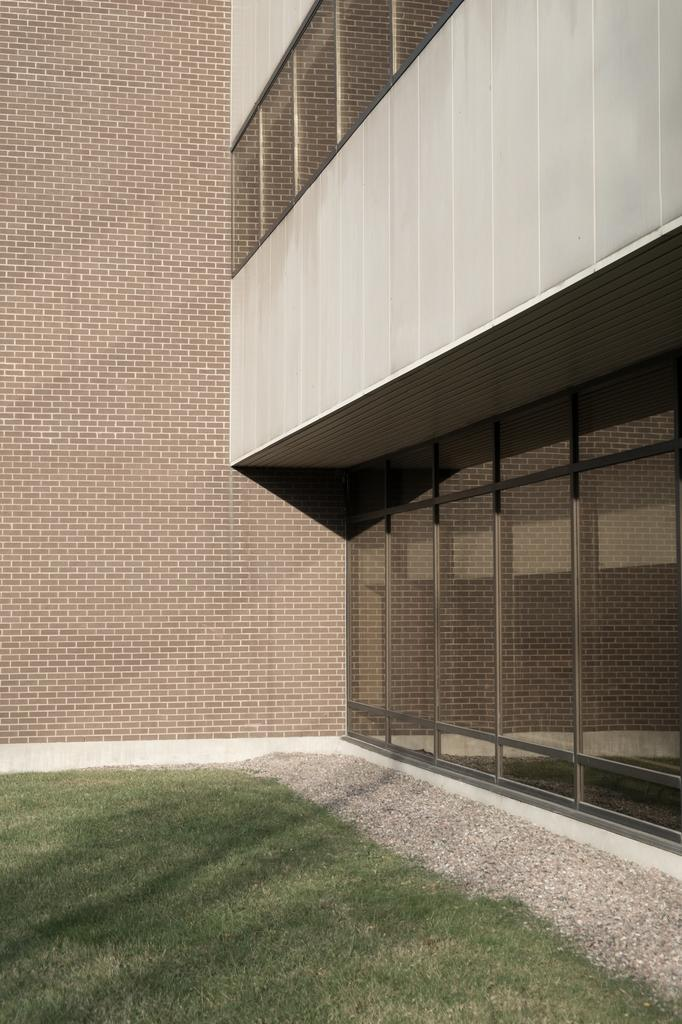What type of vegetation is present in the image? There is grass in the image. What type of structure can be seen in the image? There is a building in the image. What can be seen in the background of the image? There is a wall visible in the background of the image. Is there a man watering the grass with a hydrant in the image? There is no man or hydrant present in the image. What type of plant is growing on the wall in the image? There is no plant growing on the wall in the image; only a wall is visible in the background. 